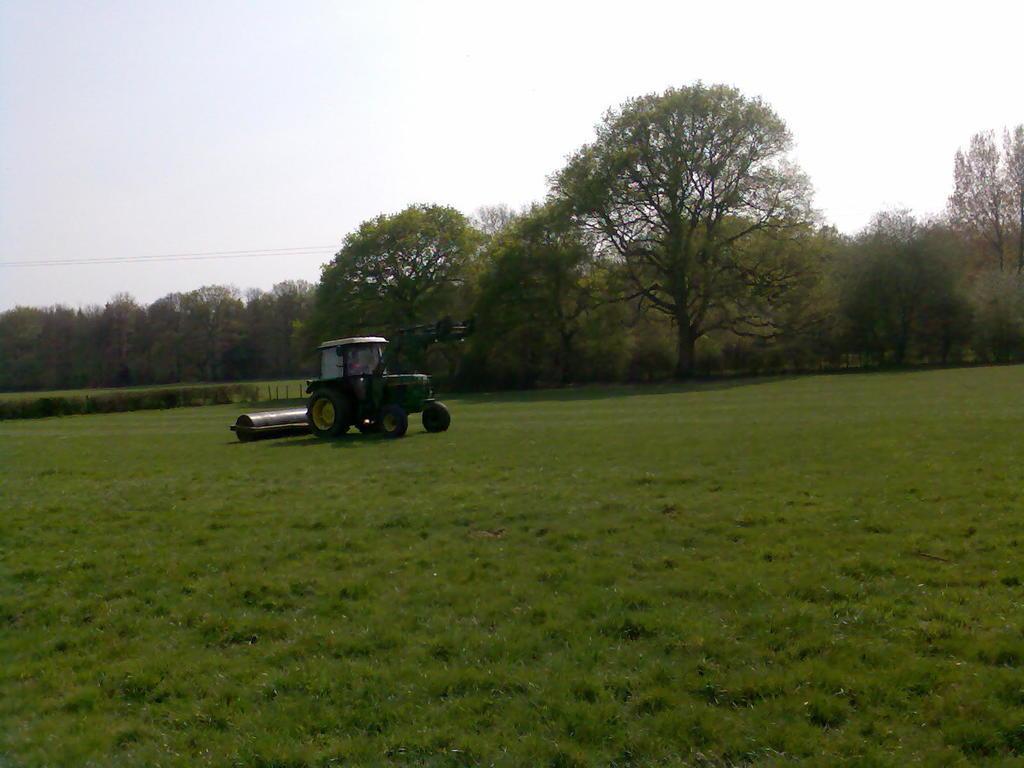How would you summarize this image in a sentence or two? In this image I can see an open grass ground and on it I can see a green colour tractor. In the background I can see number of trees, wires and the sky. 